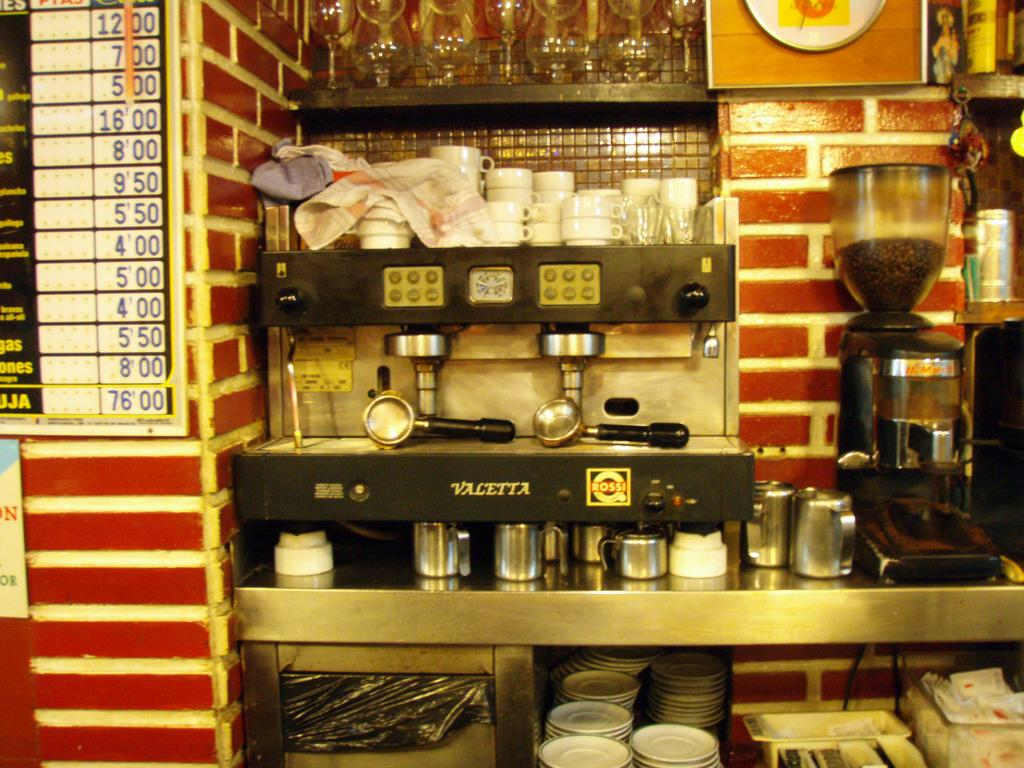<image>
Summarize the visual content of the image. Kitchen showing a coffee maker and an item that says Valetta. 